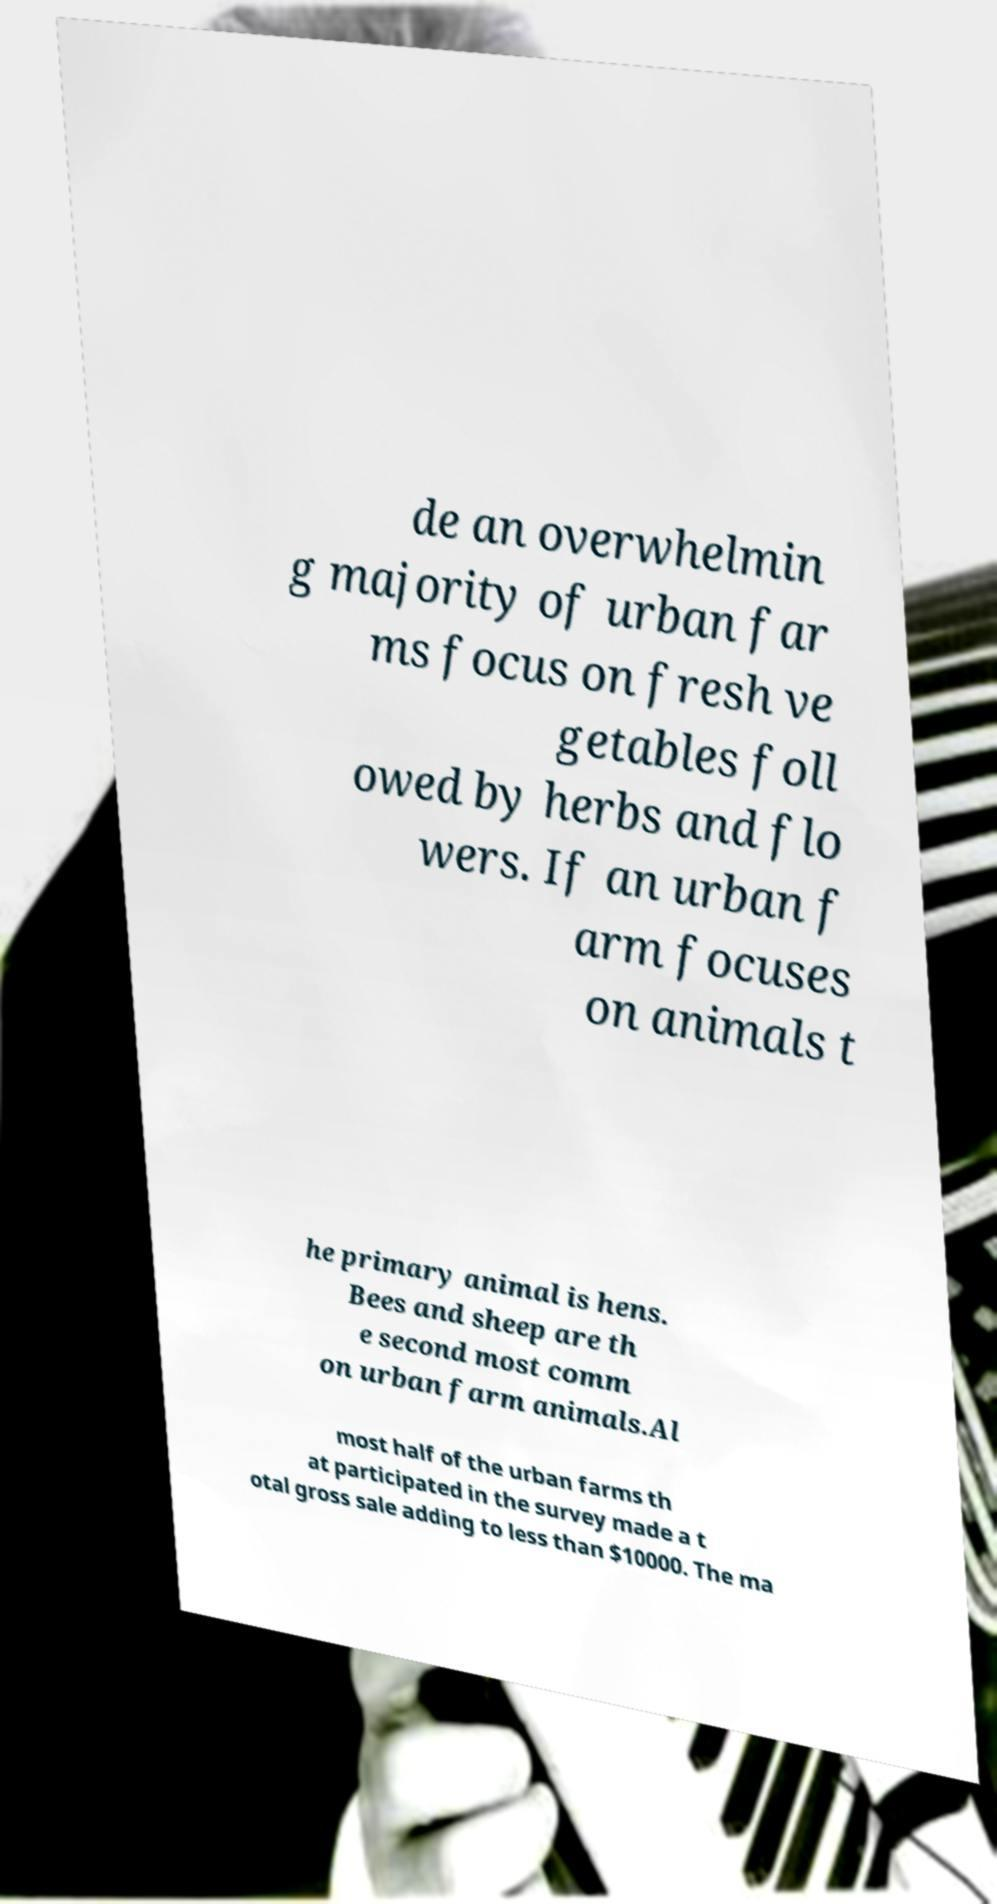Please identify and transcribe the text found in this image. de an overwhelmin g majority of urban far ms focus on fresh ve getables foll owed by herbs and flo wers. If an urban f arm focuses on animals t he primary animal is hens. Bees and sheep are th e second most comm on urban farm animals.Al most half of the urban farms th at participated in the survey made a t otal gross sale adding to less than $10000. The ma 